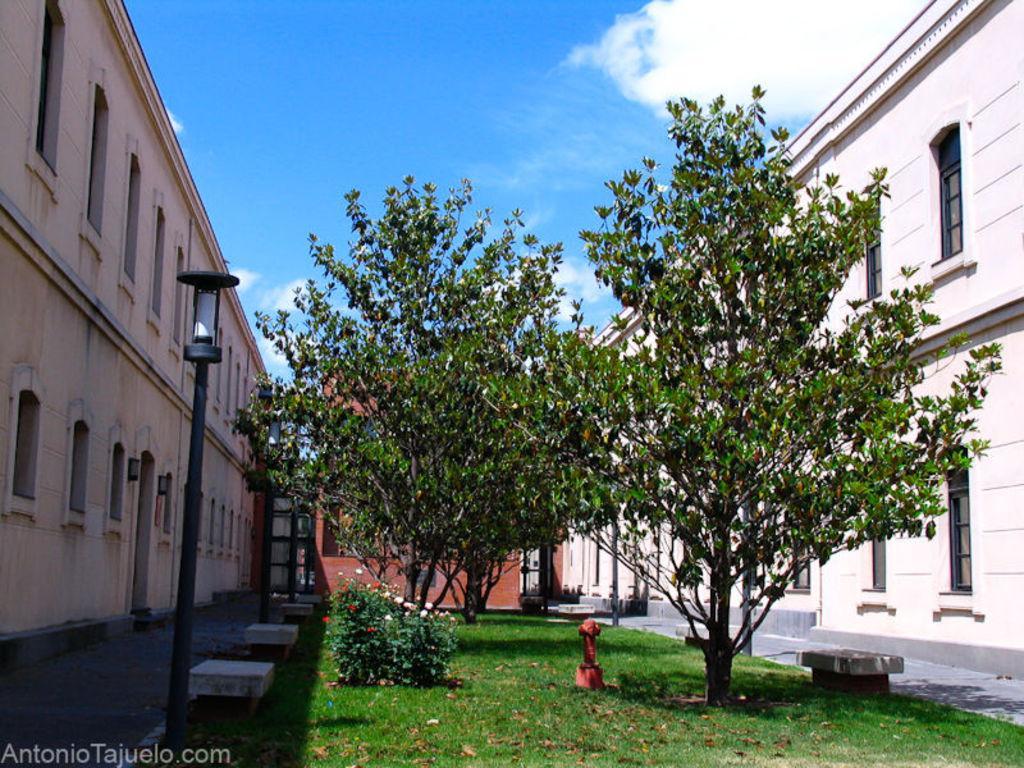Can you describe this image briefly? In this picture we can see buildings, at the bottom there is grass, we can see trees and a flower plant in the middle, on the left side there are poles and lights, we can see the sky at the top of the picture. 